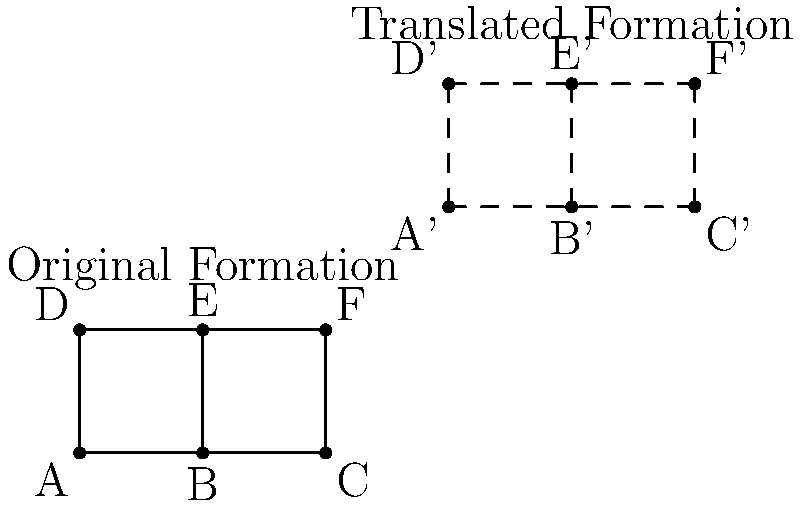In the Battle of Trafalgar (1805), Admiral Nelson's fleet adopted a unique formation to break through the Franco-Spanish line. The diagram shows a simplified version of this formation. If the entire formation is translated by the vector $\vec{v} = (3, 2)$, what are the coordinates of point E' (the new position of ship E) after the translation? To find the coordinates of point E' after the translation, we need to follow these steps:

1. Identify the original coordinates of point E:
   E is located at (1, 1) in the original formation.

2. Understand the translation vector:
   The translation vector is $\vec{v} = (3, 2)$.

3. Apply the translation:
   To translate a point, we add the components of the translation vector to the coordinates of the original point.
   
   For point E:
   x-coordinate: $1 + 3 = 4$
   y-coordinate: $1 + 2 = 3$

4. Determine the new coordinates:
   After translation, E' will be at (4, 3).

This translation represents how the entire fleet formation would move together while maintaining its shape, which was crucial for executing Nelson's strategy at Trafalgar.
Answer: (4, 3) 